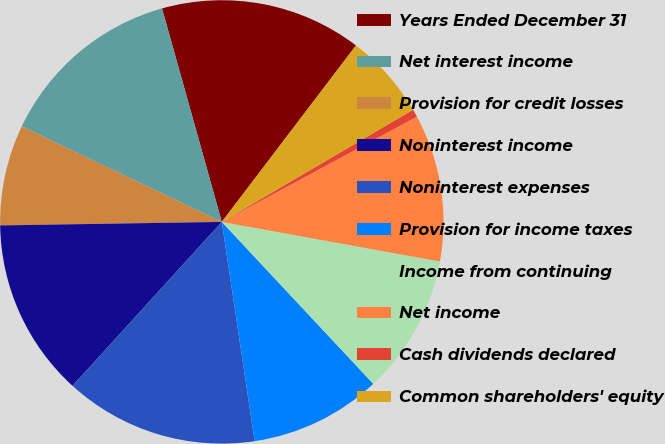Convert chart. <chart><loc_0><loc_0><loc_500><loc_500><pie_chart><fcel>Years Ended December 31<fcel>Net interest income<fcel>Provision for credit losses<fcel>Noninterest income<fcel>Noninterest expenses<fcel>Provision for income taxes<fcel>Income from continuing<fcel>Net income<fcel>Cash dividends declared<fcel>Common shareholders' equity<nl><fcel>14.69%<fcel>13.56%<fcel>7.34%<fcel>12.99%<fcel>14.12%<fcel>9.6%<fcel>10.17%<fcel>10.73%<fcel>0.57%<fcel>6.21%<nl></chart> 